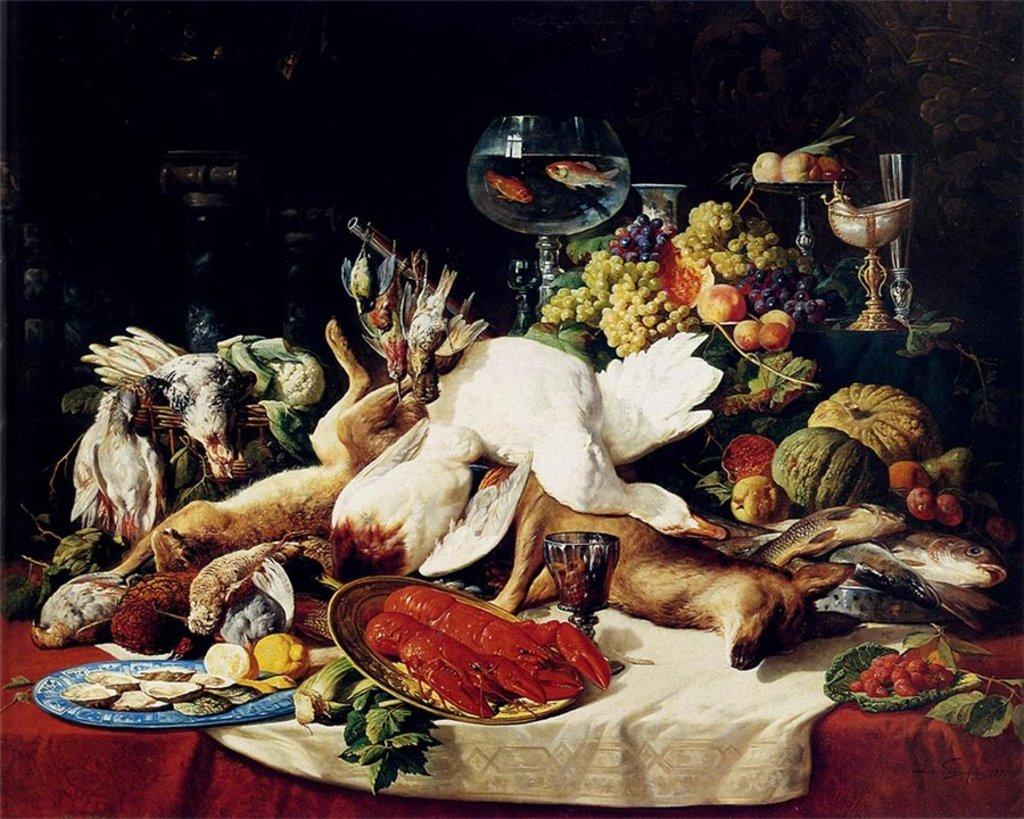What is the main subject of the image? The main subject of the image is a depiction of dead animals. What objects are present in the image besides the dead animals? There are plates, glasses, fruits, vegetables, and clothes in the image. What type of food items can be seen in the image? Fruits and vegetables are present in the image. What might be used for serving or drinking in the image? Plates and glasses are present in the image for serving and drinking. What type of plot is being discussed in the image? There is no plot being discussed in the image, as it is a still image and not a conversation or story. What type of treatment is being administered to the dead animals in the image? There is no treatment being administered to the dead animals in the image, as they are already deceased. 